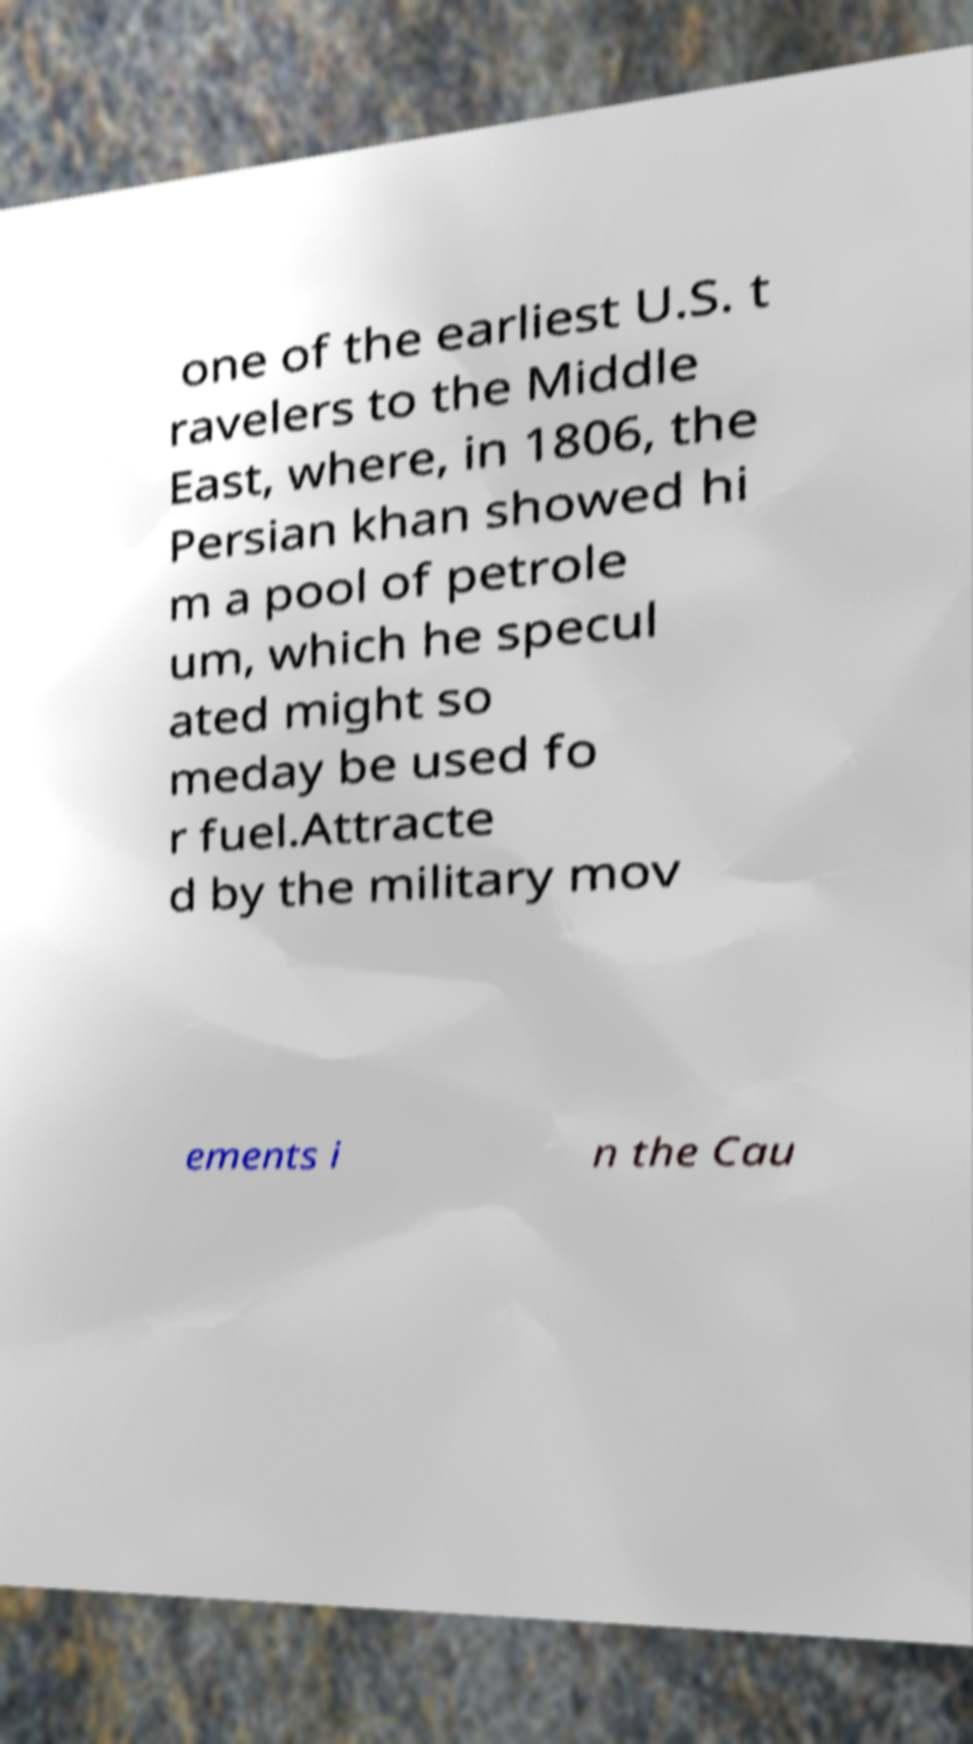What messages or text are displayed in this image? I need them in a readable, typed format. one of the earliest U.S. t ravelers to the Middle East, where, in 1806, the Persian khan showed hi m a pool of petrole um, which he specul ated might so meday be used fo r fuel.Attracte d by the military mov ements i n the Cau 